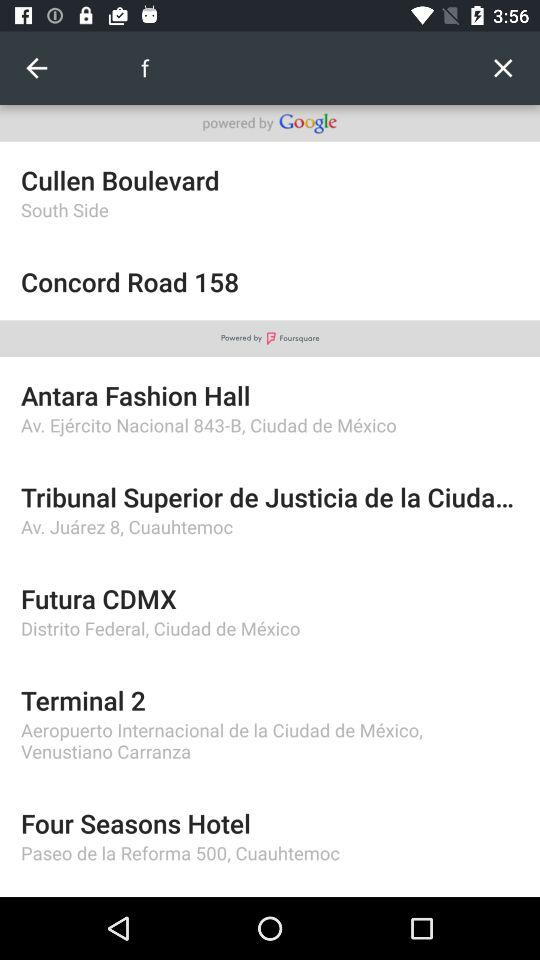What is the address of "Antara Fashion Hall"? The address is Av. Ejercito Nacional 843-B, Ciudad de Mexico. 